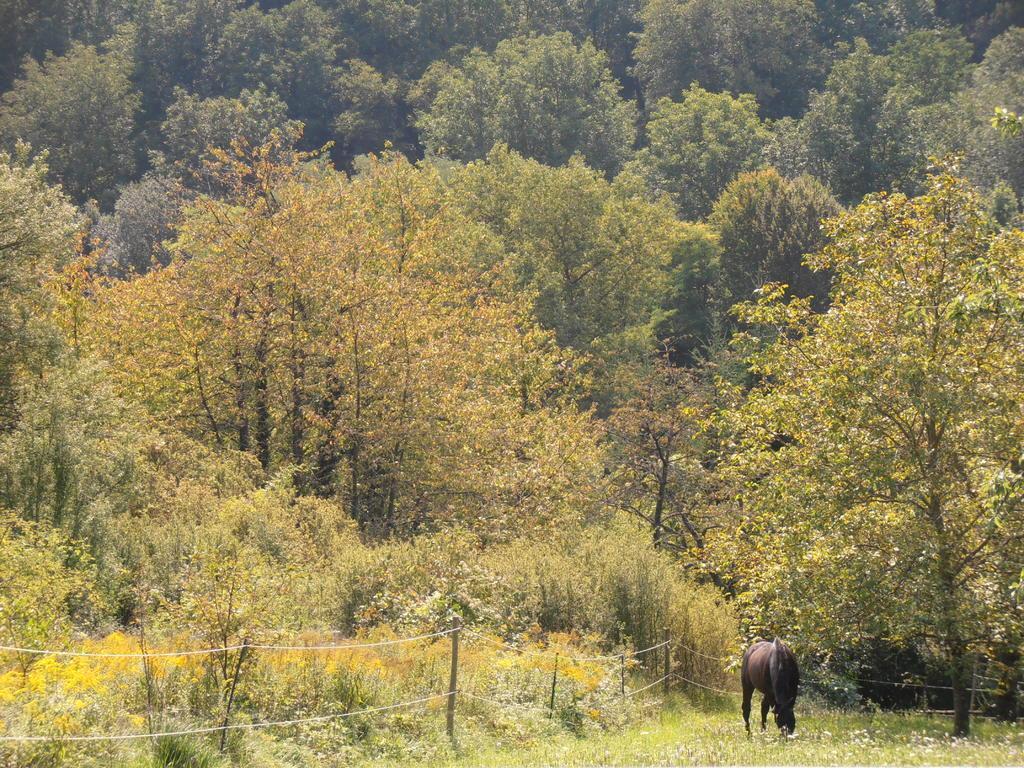How would you summarize this image in a sentence or two? At the bottom of the image we can see a grass and horse. In the background we can see fencing and trees. 